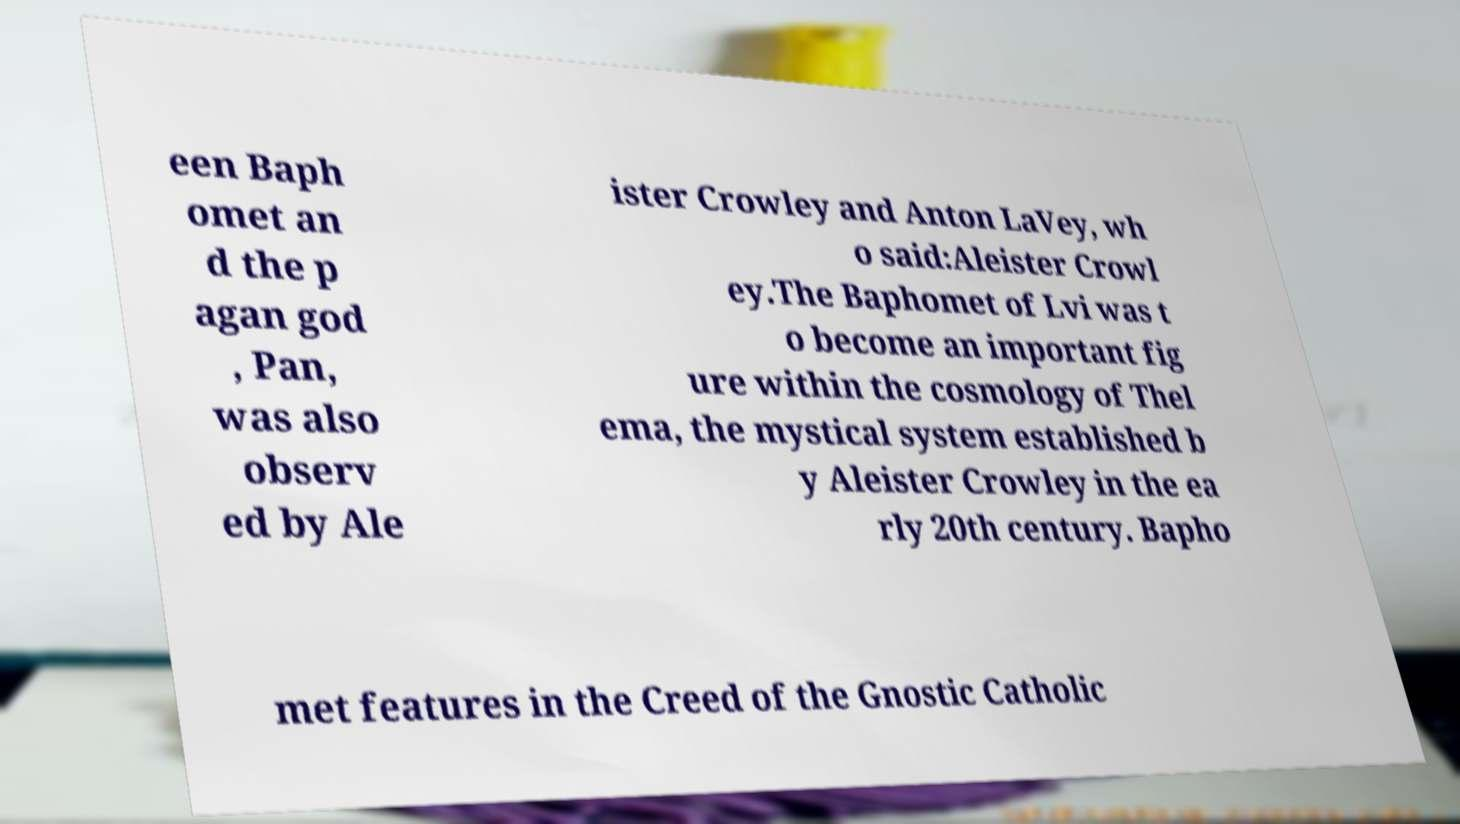For documentation purposes, I need the text within this image transcribed. Could you provide that? een Baph omet an d the p agan god , Pan, was also observ ed by Ale ister Crowley and Anton LaVey, wh o said:Aleister Crowl ey.The Baphomet of Lvi was t o become an important fig ure within the cosmology of Thel ema, the mystical system established b y Aleister Crowley in the ea rly 20th century. Bapho met features in the Creed of the Gnostic Catholic 